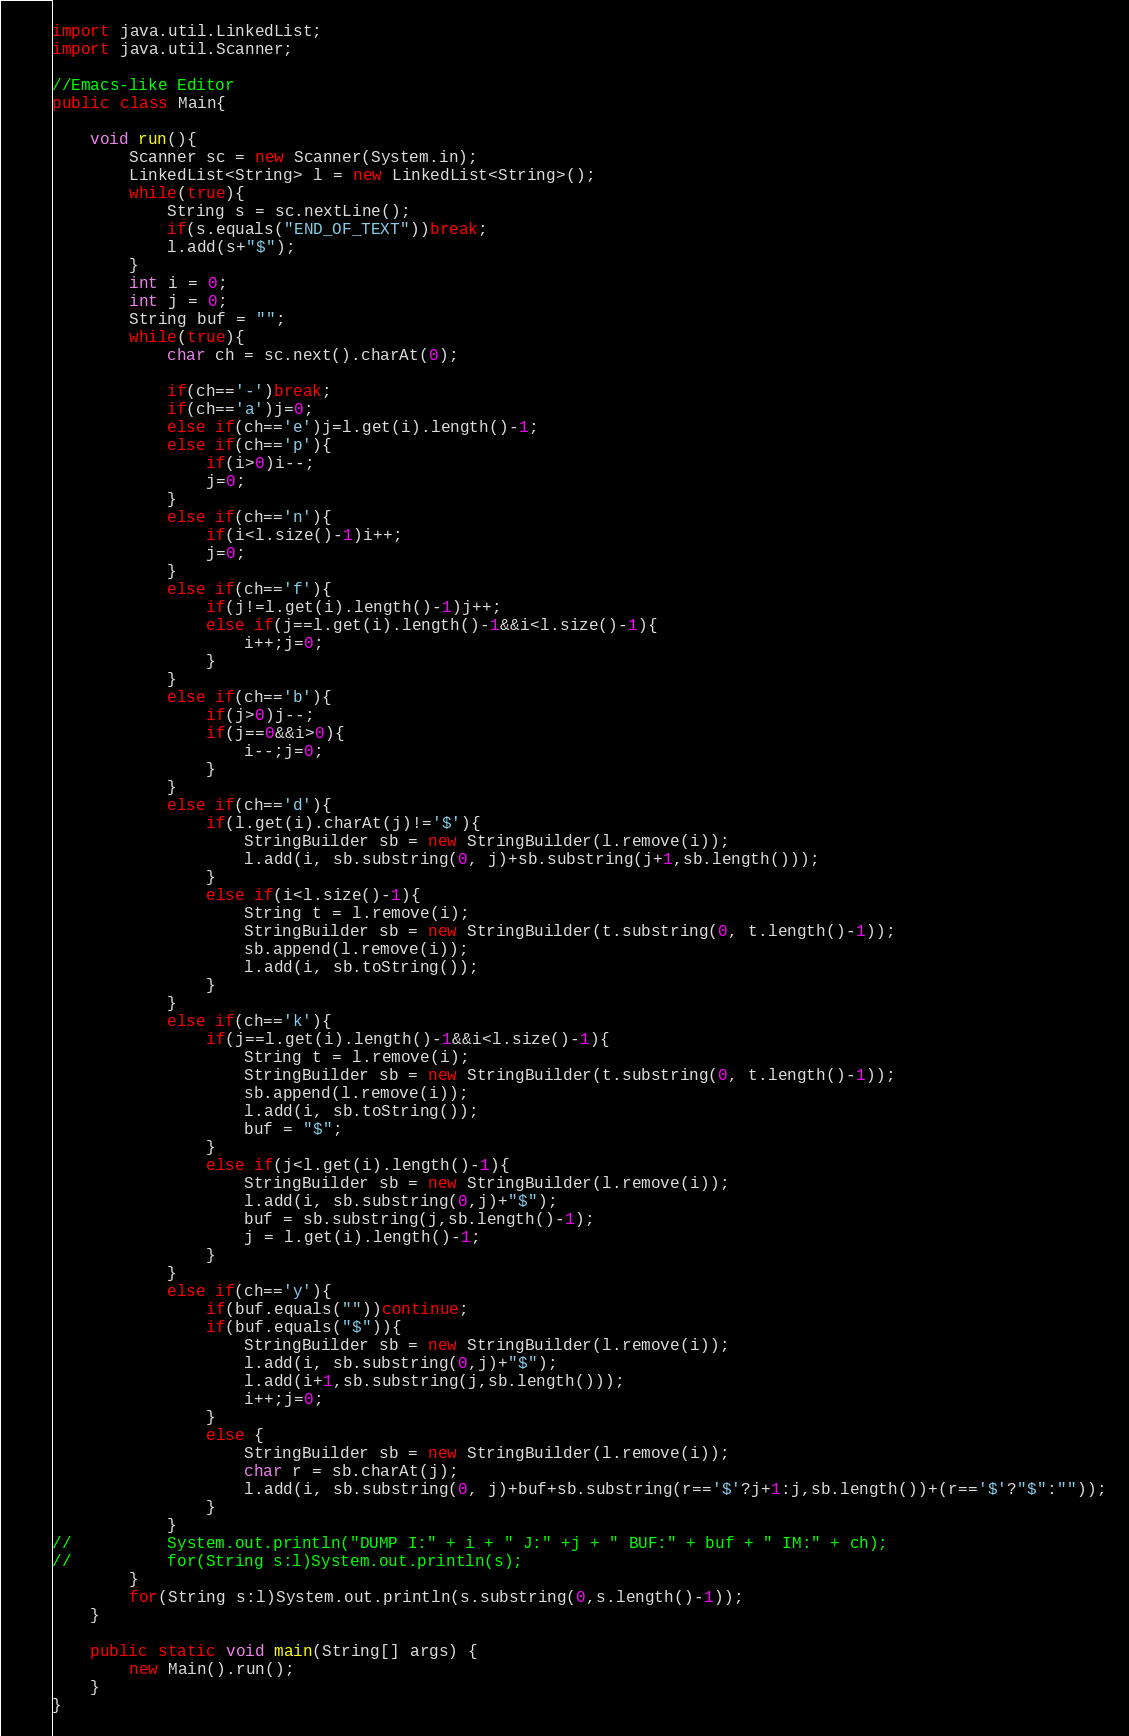<code> <loc_0><loc_0><loc_500><loc_500><_Java_>import java.util.LinkedList;
import java.util.Scanner;

//Emacs-like Editor
public class Main{

	void run(){
		Scanner sc = new Scanner(System.in);
		LinkedList<String> l = new LinkedList<String>();
		while(true){
			String s = sc.nextLine();
			if(s.equals("END_OF_TEXT"))break;
			l.add(s+"$");
		}
		int i = 0;
		int j = 0;
		String buf = "";
		while(true){
			char ch = sc.next().charAt(0);
			
			if(ch=='-')break;
			if(ch=='a')j=0;
			else if(ch=='e')j=l.get(i).length()-1;
			else if(ch=='p'){
				if(i>0)i--;
				j=0;
			}
			else if(ch=='n'){
				if(i<l.size()-1)i++;
				j=0;
			}
			else if(ch=='f'){
				if(j!=l.get(i).length()-1)j++;
				else if(j==l.get(i).length()-1&&i<l.size()-1){
					i++;j=0;
				}
			}
			else if(ch=='b'){
				if(j>0)j--;
				if(j==0&&i>0){
					i--;j=0;
				}
			}
			else if(ch=='d'){
				if(l.get(i).charAt(j)!='$'){
					StringBuilder sb = new StringBuilder(l.remove(i));
					l.add(i, sb.substring(0, j)+sb.substring(j+1,sb.length()));
				}
				else if(i<l.size()-1){
					String t = l.remove(i);
					StringBuilder sb = new StringBuilder(t.substring(0, t.length()-1));
					sb.append(l.remove(i));
					l.add(i, sb.toString());
				}
			}
			else if(ch=='k'){
				if(j==l.get(i).length()-1&&i<l.size()-1){
					String t = l.remove(i);
					StringBuilder sb = new StringBuilder(t.substring(0, t.length()-1));
					sb.append(l.remove(i));
					l.add(i, sb.toString());
					buf = "$";
				}
				else if(j<l.get(i).length()-1){
					StringBuilder sb = new StringBuilder(l.remove(i));
					l.add(i, sb.substring(0,j)+"$");
					buf = sb.substring(j,sb.length()-1);
					j = l.get(i).length()-1;
				}
			}
			else if(ch=='y'){
				if(buf.equals(""))continue;
				if(buf.equals("$")){
					StringBuilder sb = new StringBuilder(l.remove(i));
					l.add(i, sb.substring(0,j)+"$");
					l.add(i+1,sb.substring(j,sb.length()));
					i++;j=0;
				}
				else {
					StringBuilder sb = new StringBuilder(l.remove(i));
					char r = sb.charAt(j);
					l.add(i, sb.substring(0, j)+buf+sb.substring(r=='$'?j+1:j,sb.length())+(r=='$'?"$":""));
				}
			}
//			System.out.println("DUMP I:" + i + " J:" +j + " BUF:" + buf + " IM:" + ch);
//			for(String s:l)System.out.println(s);
		}
		for(String s:l)System.out.println(s.substring(0,s.length()-1));
	}
	
	public static void main(String[] args) {
		new Main().run();
	}
}</code> 